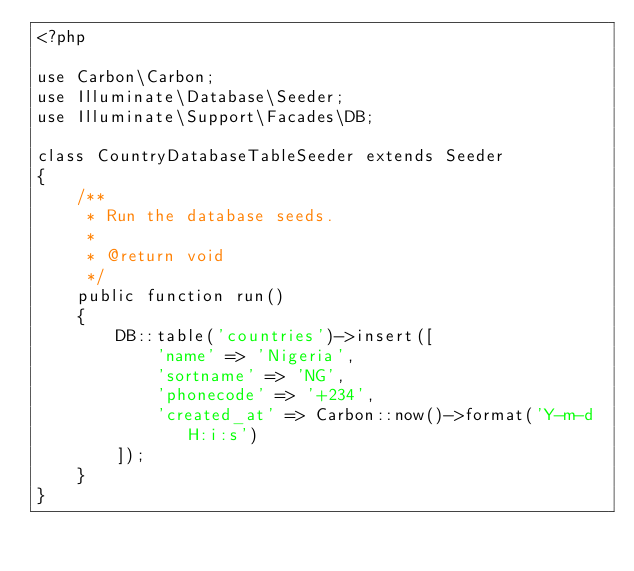Convert code to text. <code><loc_0><loc_0><loc_500><loc_500><_PHP_><?php

use Carbon\Carbon;
use Illuminate\Database\Seeder;
use Illuminate\Support\Facades\DB;

class CountryDatabaseTableSeeder extends Seeder
{
    /**
     * Run the database seeds.
     *
     * @return void
     */
    public function run()
    {
        DB::table('countries')->insert([
            'name' => 'Nigeria',
            'sortname' => 'NG',
            'phonecode' => '+234',
            'created_at' => Carbon::now()->format('Y-m-d H:i:s')
        ]);
    }
}
</code> 